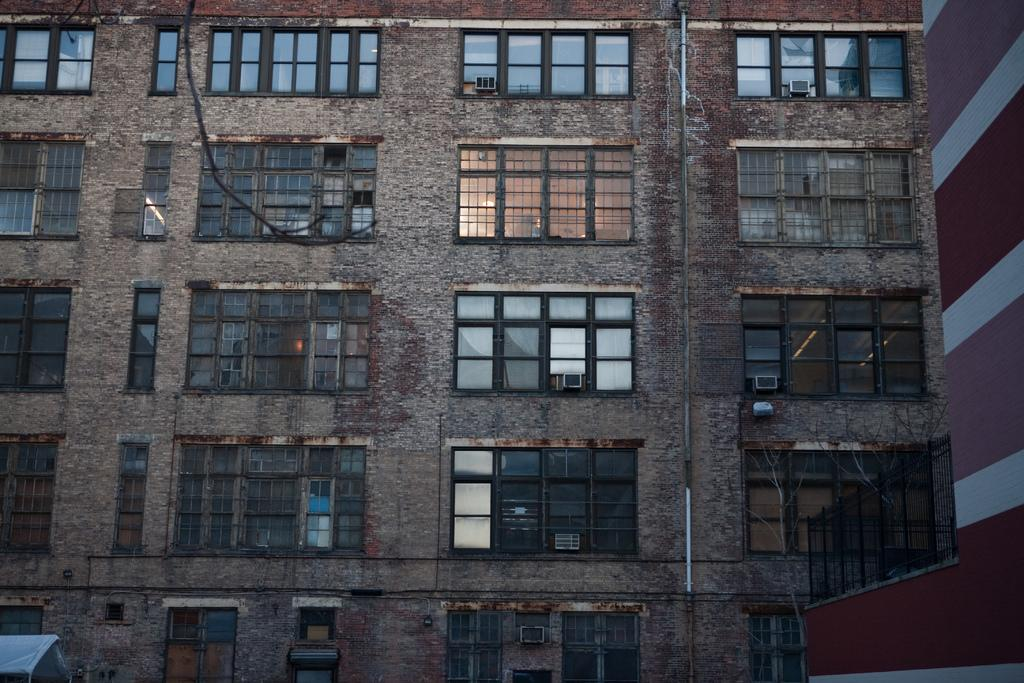What type of structure is visible in the image? There is a building in the image. What feature can be observed on the building? The building has glass windows. What type of payment is required to enter the building in the image? There is no information about payment or entering the building in the image. 